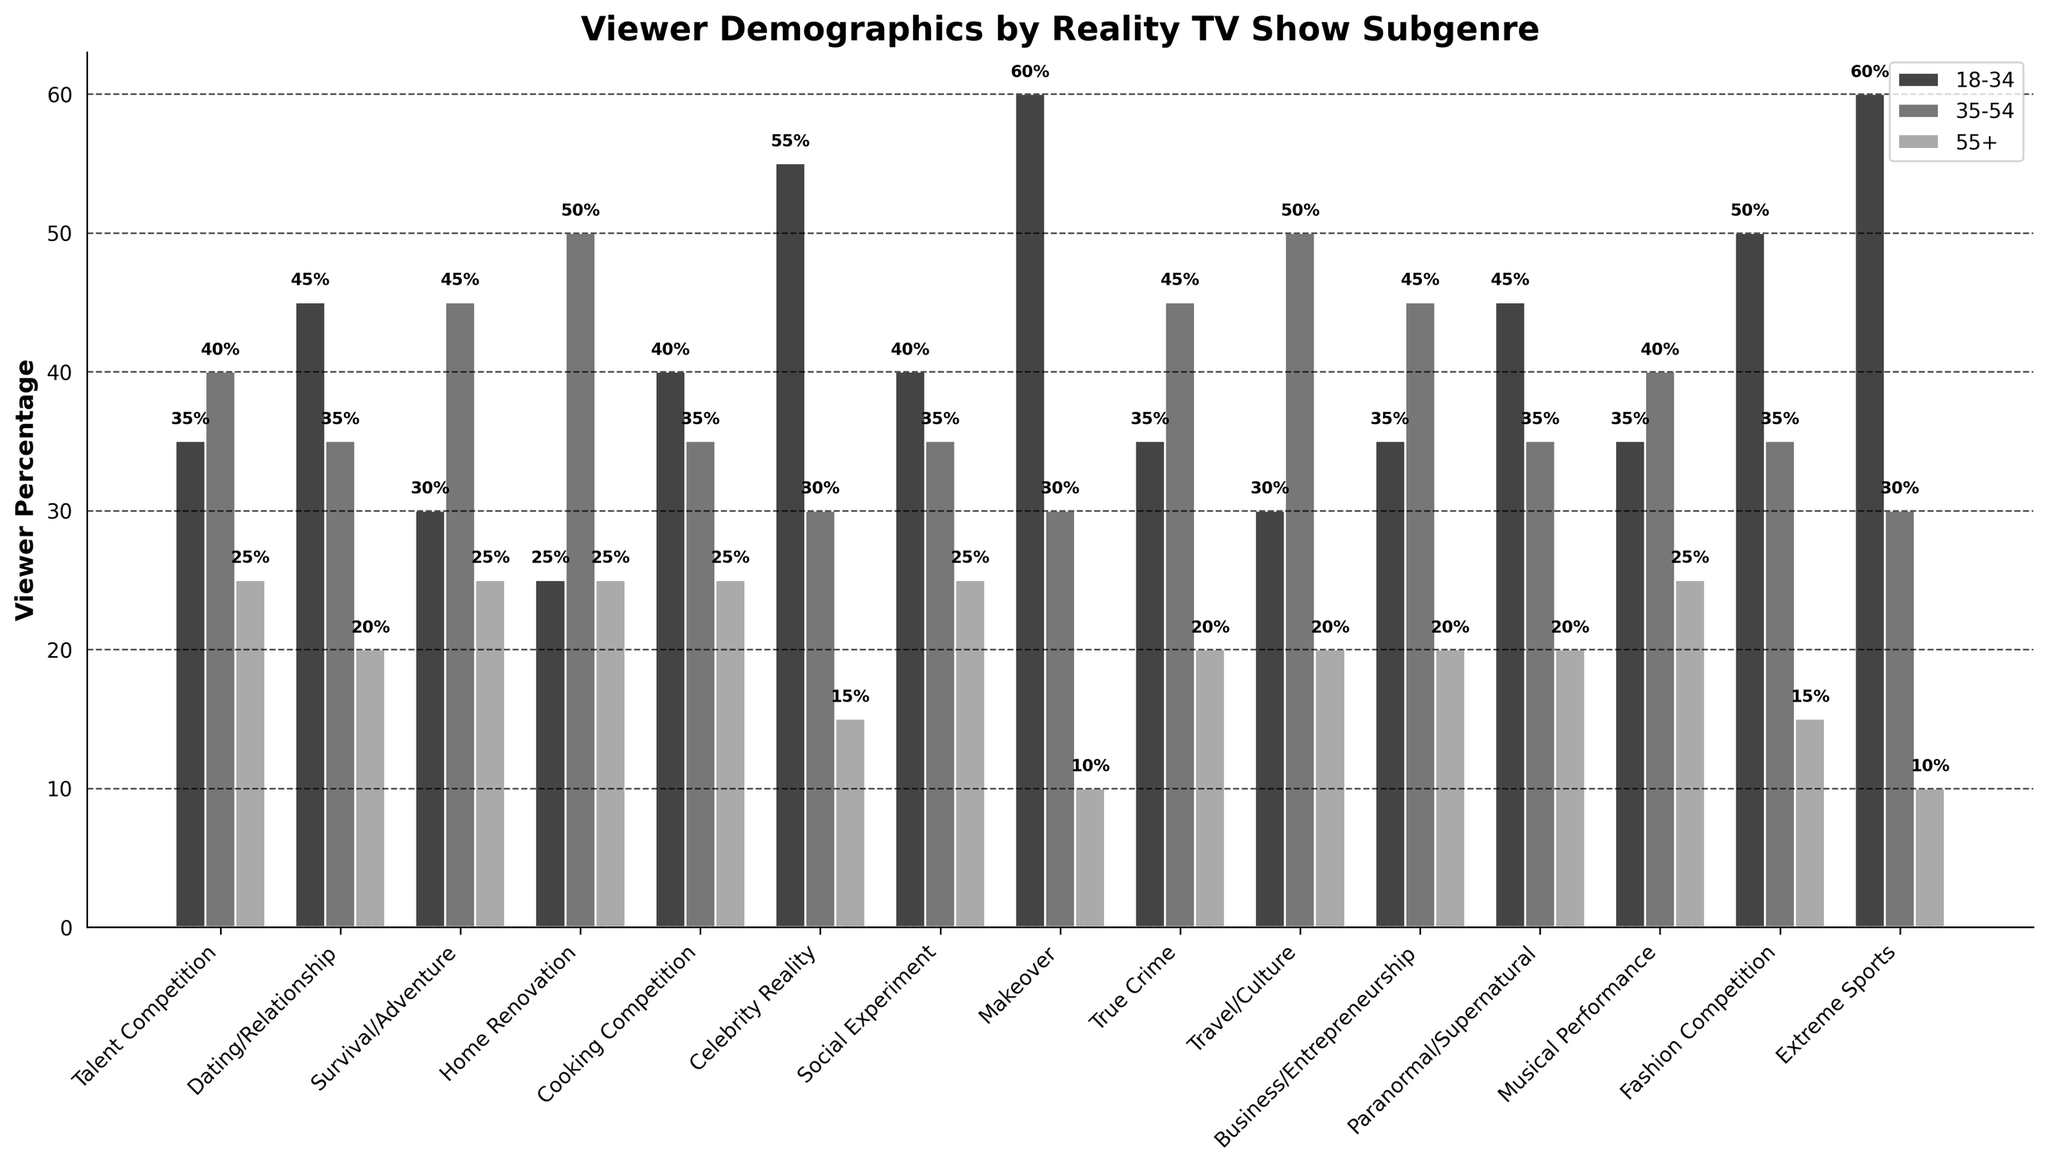Which subgenre has the highest percentage of viewers aged 18-34? By looking at the heights of the bars for the 18-34 age group, we can see that "Queer Eye" has the tallest bar, indicating the highest percentage of viewers aged 18-34.
Answer: Queer Eye What is the total percentage of viewers aged 55+ across all subgenres? To find the total percentage of viewers aged 55+ across all subgenres, sum up the values for each subgenre provided in the 55+ column: 25 + 20 + 25 + 25 + 25 + 15 + 25 + 10 + 20 + 20 + 20 + 20 + 25 + 15 + 10 = 290%.
Answer: 290% How many subgenres have a higher percentage of 35-54 viewers than 18-34 viewers? We need to compare the percentages of 35-54 viewers and 18-34 viewers for each subgenre and count how many times the former is greater than the latter. These subgenres are "American Idol", "Survivor", "Fixer Upper", "Anthony Bourdain: Parts Unknown", "Shark Tank". Thus, there are 5 subgenres.
Answer: 5 What is the average percentage of viewers aged 18-34 across all subgenres? To find the average, sum up the percentages of viewers aged 18-34 for each subgenre and divide by the number of subgenres: (35+45+30+25+40+55+40+60+35+30+35+45+35+50+60)/15 = 565/15 ≈ 37.67%.
Answer: 37.67% Which two subgenres have the closest viewer percentages for the 55+ age group? We need to find the pair of subgenres with the smallest absolute difference in percentages for the 55+ age group. From the figure, "The Bachelor" and "True Crime" both have 20% viewers, indicating they have the closest percentages.
Answer: The Bachelor and True Crime In which subgenre does the percentage of 18-34 viewers exceed 50%? We need to look for visual bars where the 18-34 percentage is greater than 50%. Only "Keeping Up with the Kardashians", "Queer Eye", and "The Ultimate Fighter" meet this criterion.
Answer: Keeping Up with the Kardashians, Queer Eye, The Ultimate Fighter Which subgenre has the highest combined percentage of viewers in age groups 18-34 and 55+? We need to sum the percentages of viewers in the 18-34 and 55+ age groups for each subgenre and identify the highest one. For example, "American Idol": 35 + 25 = 60, "The Bachelor": 45 + 20 = 65, etc. "Queer Eye" has 60+10=70%, "The Ultimate Fighter" has 60+10=70%.
Answer: Queer Eye and The Ultimate Fighter Which subgenre has the most evenly distributed viewer demographics? By assessing the height and visual differentiation of the bars, "Fixer Upper" has 25%, 50%, and 25%, representing more even distribution among all demographics.
Answer: Fixer Upper 